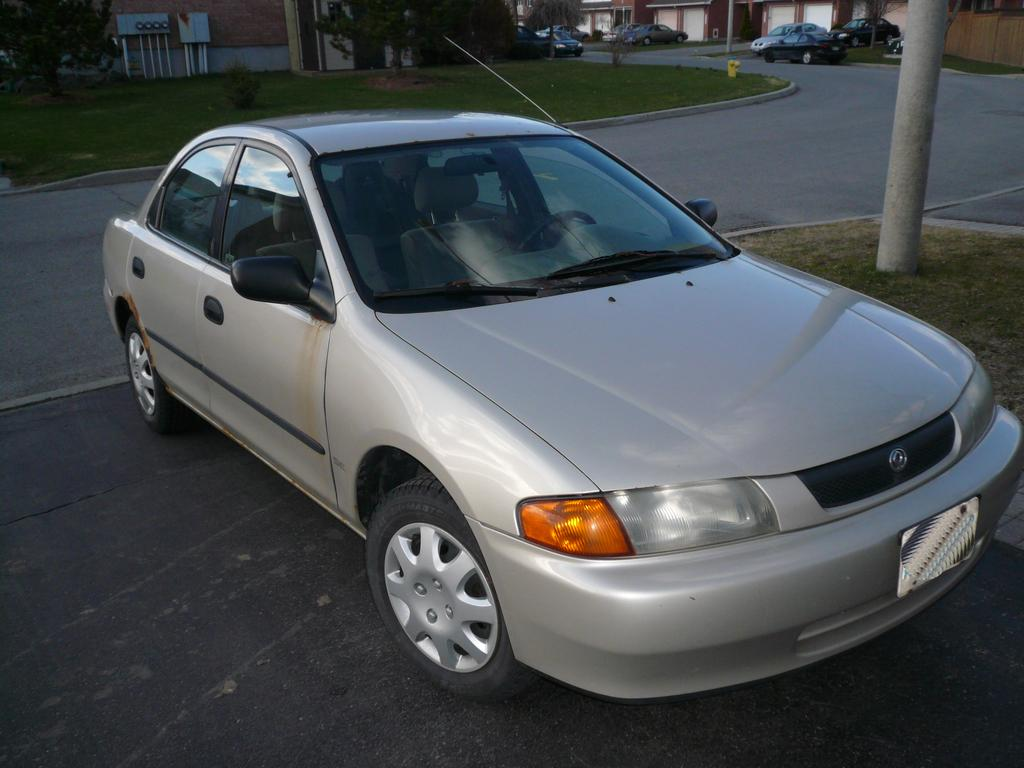What is the main subject of the image? The main subject of the image is a car. What is located near the car? There is a pole near the car. What type of surface can be seen in the image? There is a road in the image. What can be seen in the background of the image? There are cars and buildings visible in the background. What type of vegetation is present in the image? There is grass on the ground and trees in the image. What type of scarf is the horse wearing in the image? There is no horse or scarf present in the image. How does the brother interact with the car in the image? There is no brother present in the image, so it is not possible to determine how they might interact with the car. 